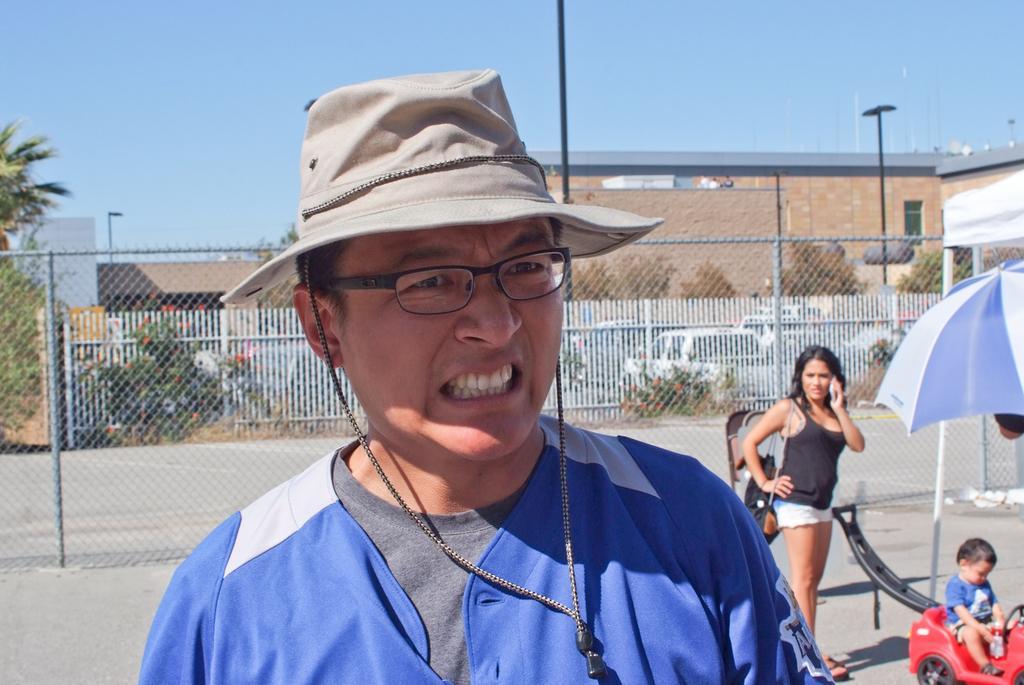Can you describe this image briefly? In the center of the image, we can see a person wearing glasses and a hat and there is a lady wearing bag and holding a mobile and there are some objects and there is a kid sitting on the toy car, there is an umbrella. In the background, we can see a mesh, fence, trees, poles and buildings. At the top, there is sky and at the bottom, there is road. 